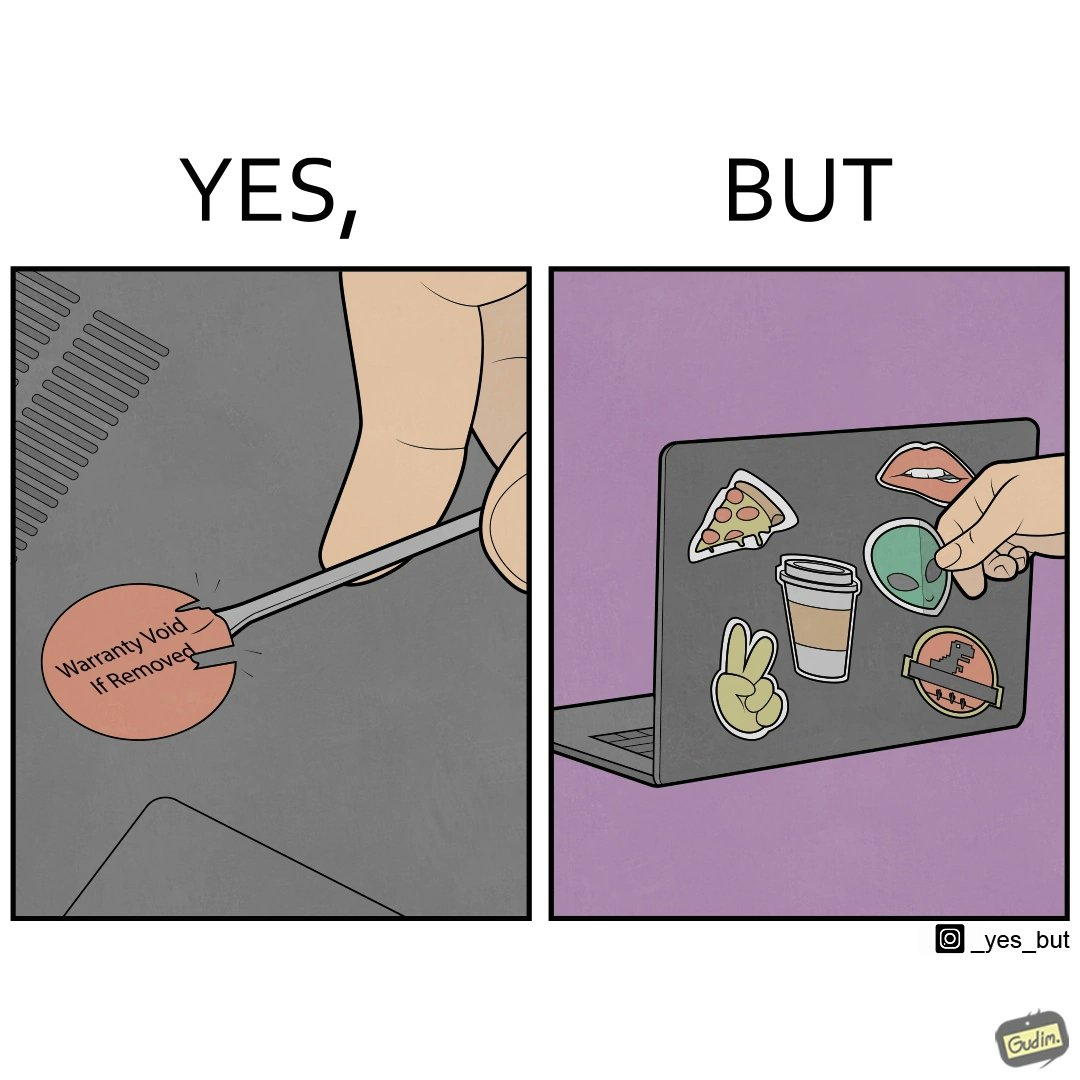Describe the satirical element in this image. The images are funny since it shows how an user chooses to remove a rather important warranty sticker because it does not look good, but chooses to fill his laptop with useless stickers just to decorate the laptop 